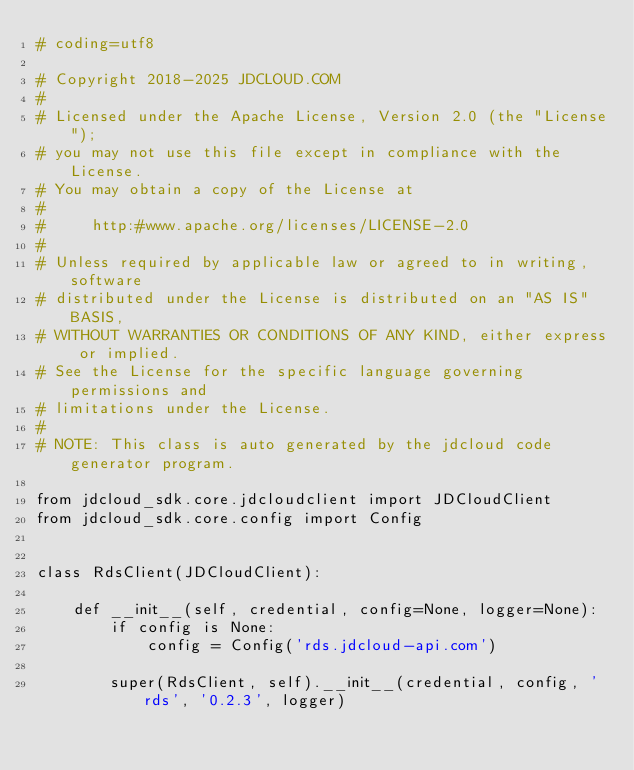<code> <loc_0><loc_0><loc_500><loc_500><_Python_># coding=utf8

# Copyright 2018-2025 JDCLOUD.COM
#
# Licensed under the Apache License, Version 2.0 (the "License");
# you may not use this file except in compliance with the License.
# You may obtain a copy of the License at
#
#     http:#www.apache.org/licenses/LICENSE-2.0
#
# Unless required by applicable law or agreed to in writing, software
# distributed under the License is distributed on an "AS IS" BASIS,
# WITHOUT WARRANTIES OR CONDITIONS OF ANY KIND, either express or implied.
# See the License for the specific language governing permissions and
# limitations under the License.
#
# NOTE: This class is auto generated by the jdcloud code generator program.

from jdcloud_sdk.core.jdcloudclient import JDCloudClient
from jdcloud_sdk.core.config import Config


class RdsClient(JDCloudClient):

    def __init__(self, credential, config=None, logger=None):
        if config is None:
            config = Config('rds.jdcloud-api.com')

        super(RdsClient, self).__init__(credential, config, 'rds', '0.2.3', logger)
</code> 